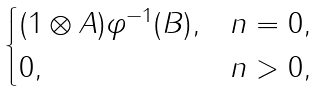Convert formula to latex. <formula><loc_0><loc_0><loc_500><loc_500>\begin{cases} ( 1 \otimes A ) \varphi ^ { - 1 } ( B ) , & n = 0 , \\ 0 , & n > 0 , \end{cases}</formula> 